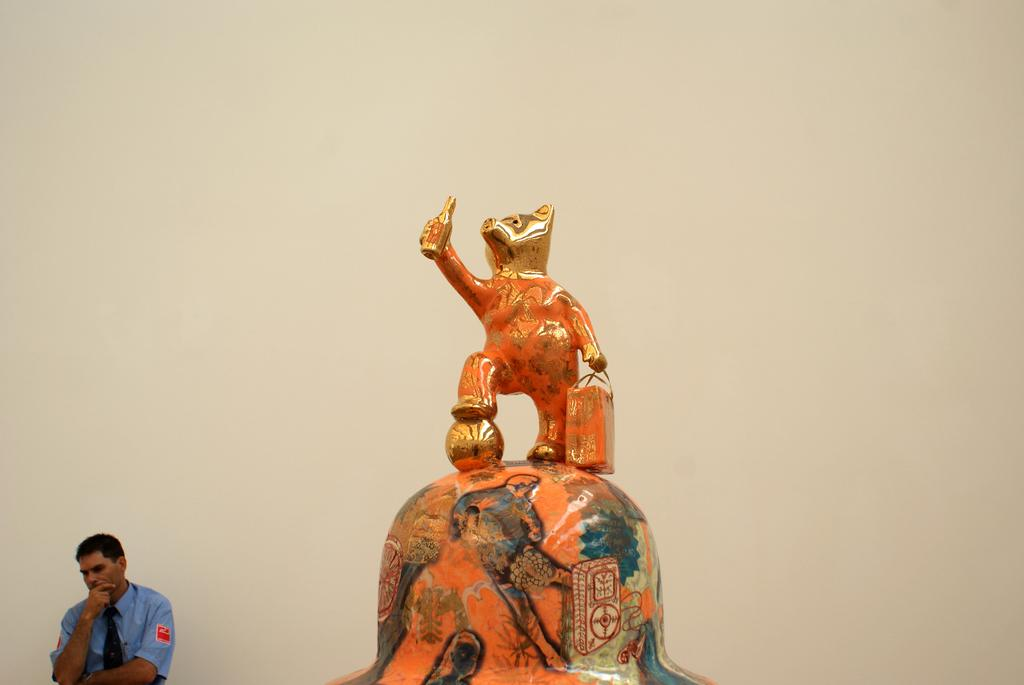What is the main subject in the image? There is a statue in the image. Are there any people in the image? Yes, there is a security person in the image. Where is the security person positioned in relation to the statue? The security person is standing near a wall. Can you describe the location of the security person in the image? The security person is located in the bottom left corner of the image. How does the security person pull the rock in the image? There is no rock present in the image, and the security person is not pulling anything. 